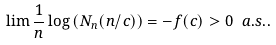Convert formula to latex. <formula><loc_0><loc_0><loc_500><loc_500>\lim \frac { 1 } { n } \log \left ( N _ { n } ( { n / c } ) \right ) = - f ( c ) > 0 \ a . s . .</formula> 